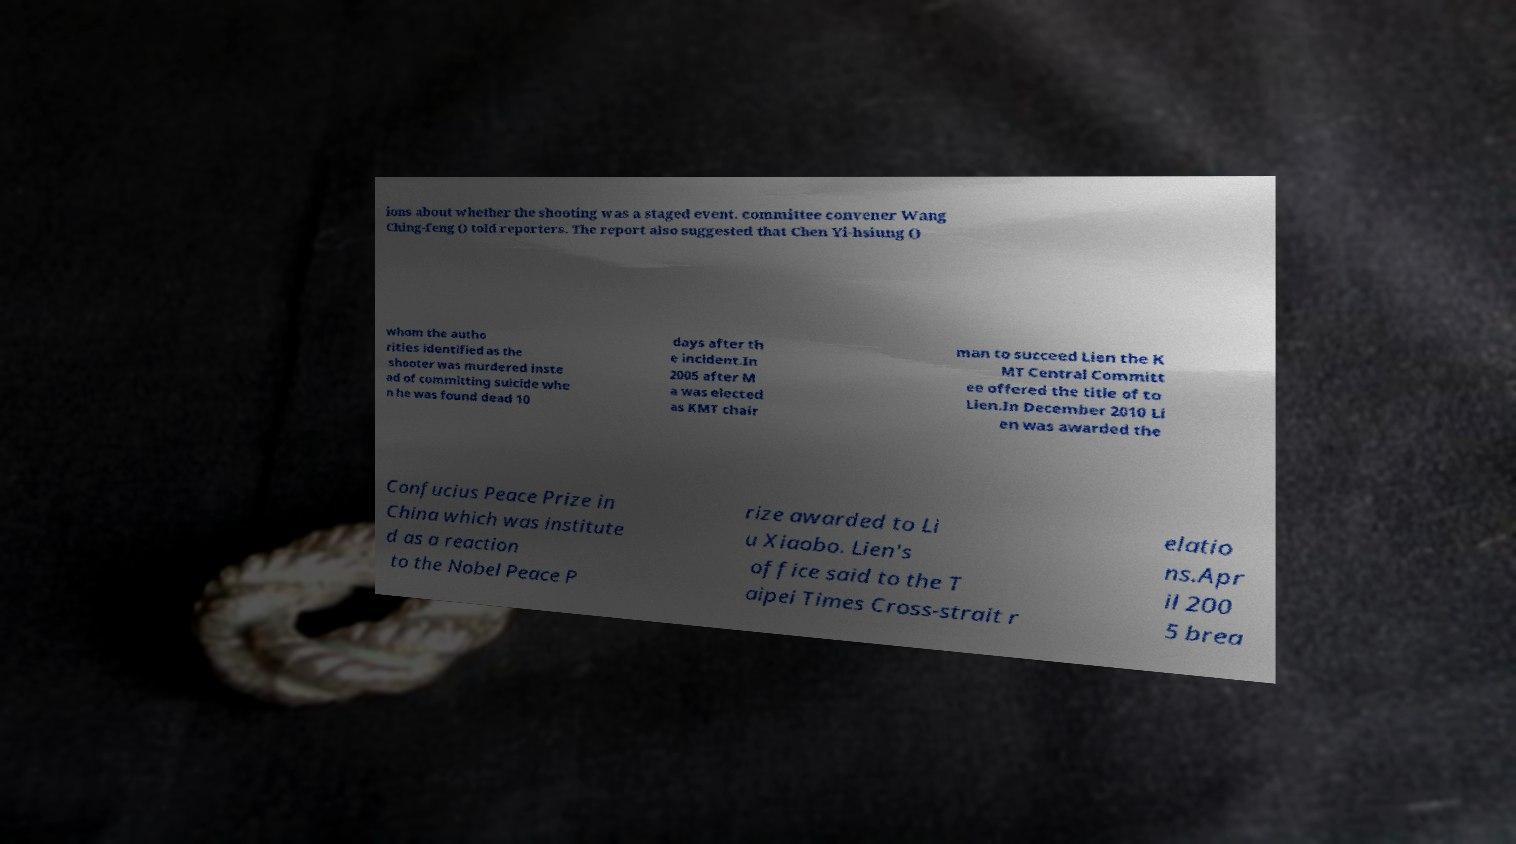Can you accurately transcribe the text from the provided image for me? ions about whether the shooting was a staged event. committee convener Wang Ching-feng () told reporters. The report also suggested that Chen Yi-hsiung () whom the autho rities identified as the shooter was murdered inste ad of committing suicide whe n he was found dead 10 days after th e incident.In 2005 after M a was elected as KMT chair man to succeed Lien the K MT Central Committ ee offered the title of to Lien.In December 2010 Li en was awarded the Confucius Peace Prize in China which was institute d as a reaction to the Nobel Peace P rize awarded to Li u Xiaobo. Lien's office said to the T aipei Times Cross-strait r elatio ns.Apr il 200 5 brea 